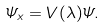Convert formula to latex. <formula><loc_0><loc_0><loc_500><loc_500>\varPsi _ { x } = V ( \lambda ) \varPsi .</formula> 